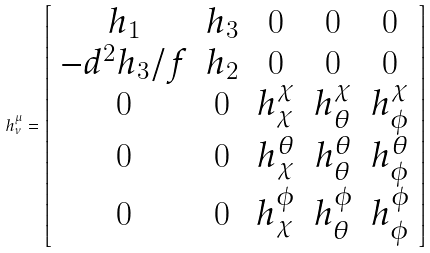<formula> <loc_0><loc_0><loc_500><loc_500>h _ { \nu } ^ { \mu } = \left [ \begin{array} { c c c c c } { { h _ { 1 } } } & { { h _ { 3 } } } & { 0 } & { 0 } & { 0 } \\ { { - d ^ { 2 } h _ { 3 } / f } } & { { h _ { 2 } } } & { 0 } & { 0 } & { 0 } \\ { 0 } & { 0 } & { { h _ { \chi } ^ { \chi } } } & { { h _ { \theta } ^ { \chi } } } & { { h _ { \phi } ^ { \chi } } } \\ { 0 } & { 0 } & { { h _ { \chi } ^ { \theta } } } & { { h _ { \theta } ^ { \theta } } } & { { h _ { \phi } ^ { \theta } } } \\ { 0 } & { 0 } & { { h _ { \chi } ^ { \phi } } } & { { h _ { \theta } ^ { \phi } } } & { { h _ { \phi } ^ { \phi } } } \end{array} \right ]</formula> 